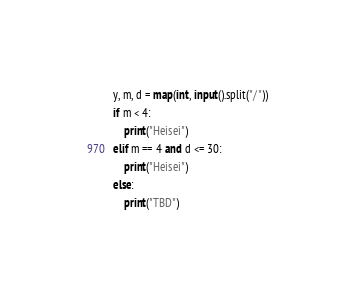Convert code to text. <code><loc_0><loc_0><loc_500><loc_500><_Python_>y, m, d = map(int, input().split("/"))
if m < 4:
    print("Heisei")
elif m == 4 and d <= 30:
    print("Heisei")
else:
    print("TBD")</code> 